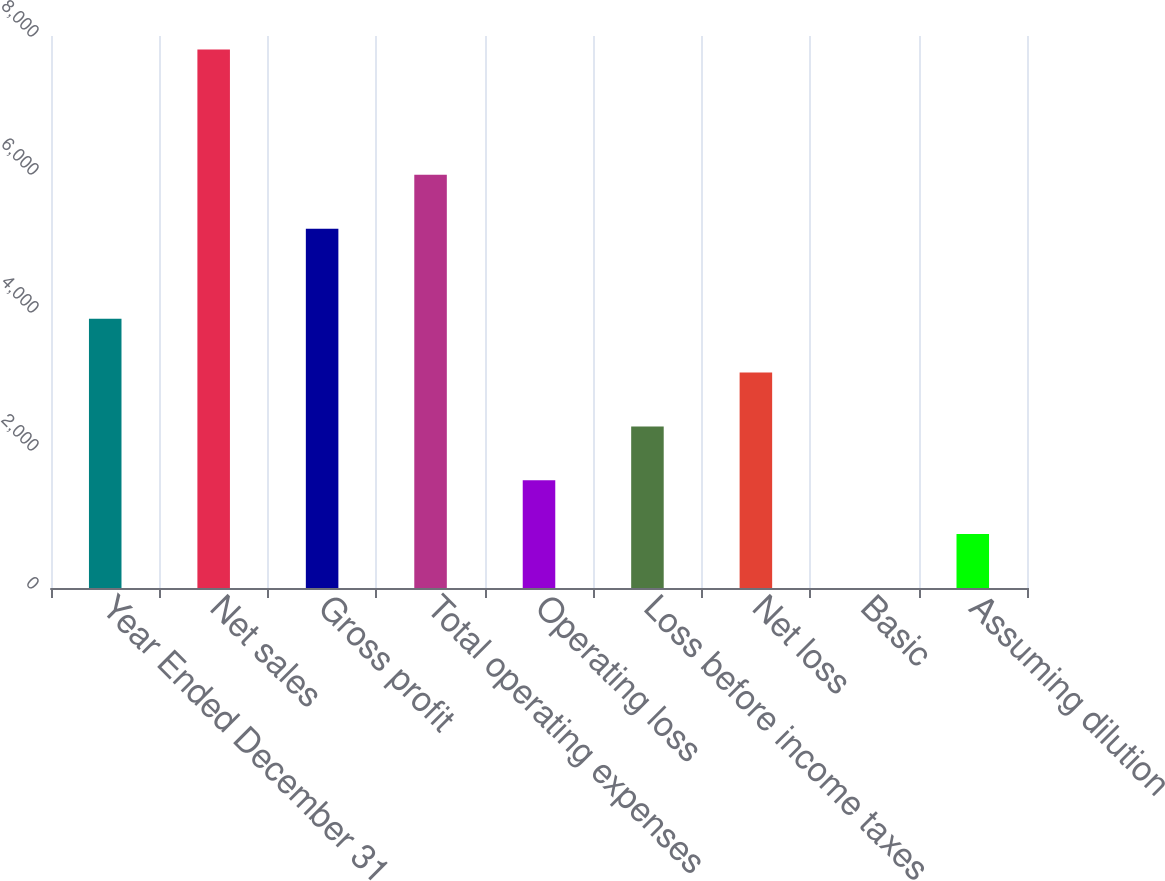Convert chart to OTSL. <chart><loc_0><loc_0><loc_500><loc_500><bar_chart><fcel>Year Ended December 31<fcel>Net sales<fcel>Gross profit<fcel>Total operating expenses<fcel>Operating loss<fcel>Loss before income taxes<fcel>Net loss<fcel>Basic<fcel>Assuming dilution<nl><fcel>3903.35<fcel>7806<fcel>5207<fcel>5987.53<fcel>1561.76<fcel>2342.29<fcel>3122.82<fcel>0.7<fcel>781.23<nl></chart> 